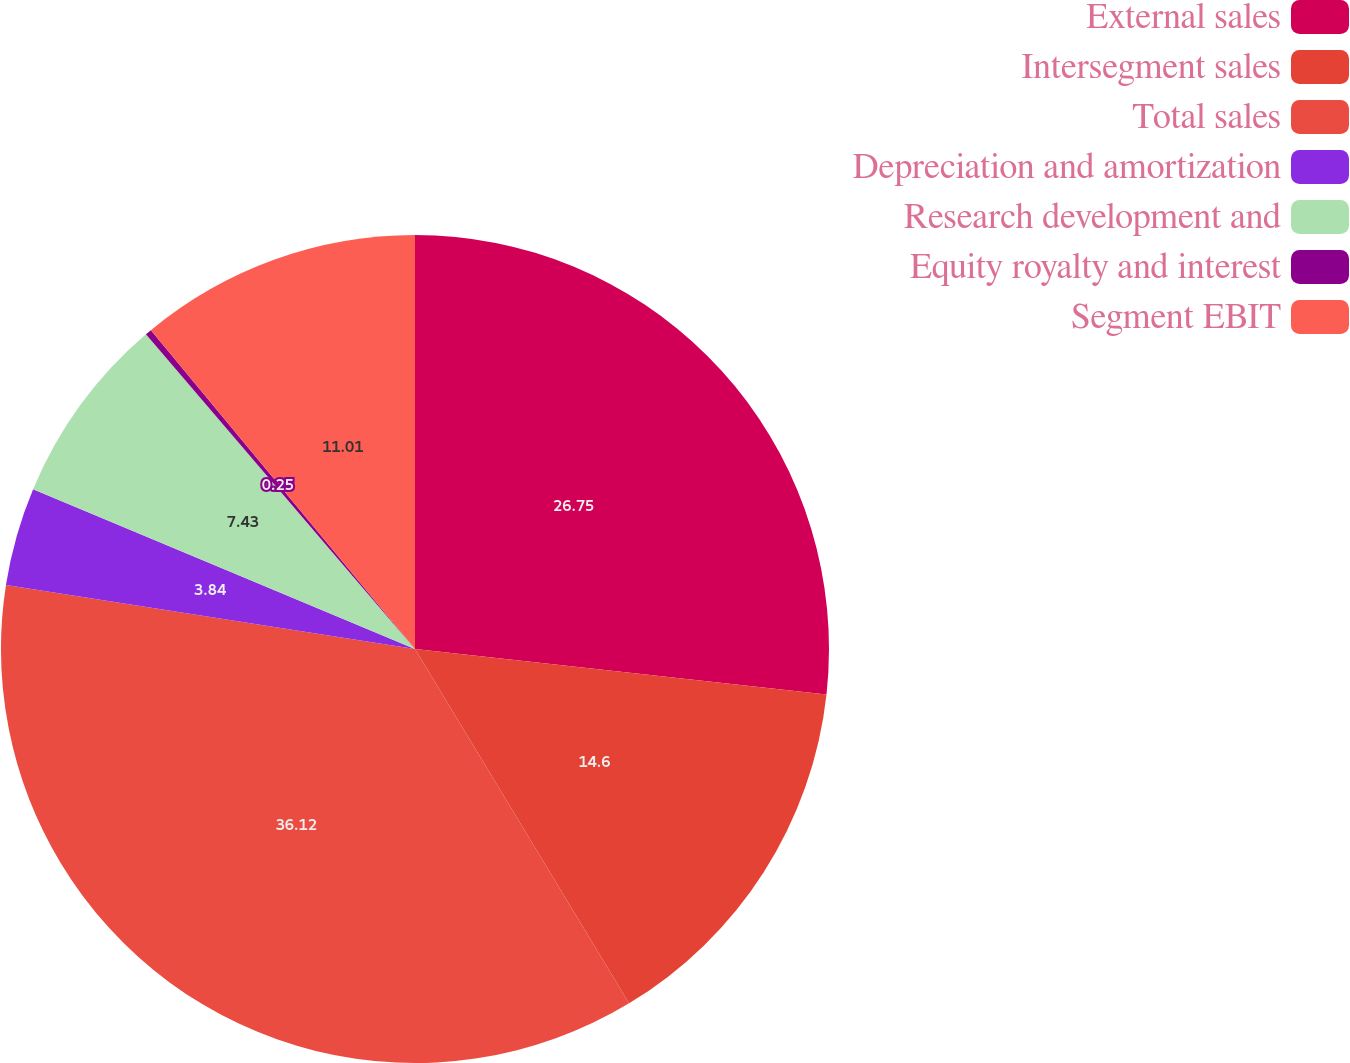Convert chart to OTSL. <chart><loc_0><loc_0><loc_500><loc_500><pie_chart><fcel>External sales<fcel>Intersegment sales<fcel>Total sales<fcel>Depreciation and amortization<fcel>Research development and<fcel>Equity royalty and interest<fcel>Segment EBIT<nl><fcel>26.75%<fcel>14.6%<fcel>36.12%<fcel>3.84%<fcel>7.43%<fcel>0.25%<fcel>11.01%<nl></chart> 